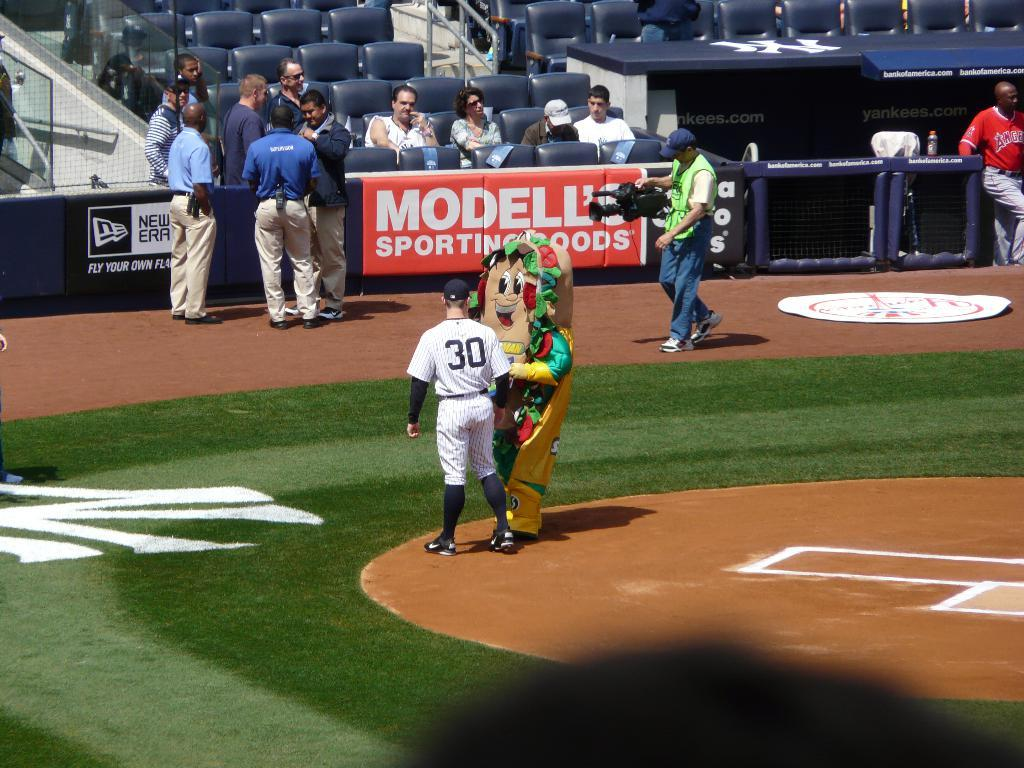Provide a one-sentence caption for the provided image. A sports field with a man in a number thirty shirt next to a mascot. 